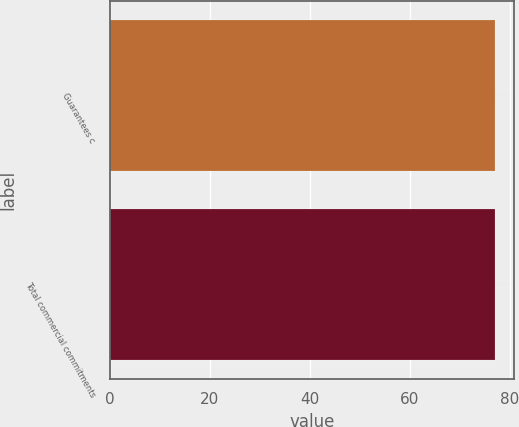Convert chart to OTSL. <chart><loc_0><loc_0><loc_500><loc_500><bar_chart><fcel>Guarantees c<fcel>Total commercial commitments<nl><fcel>77<fcel>77.1<nl></chart> 